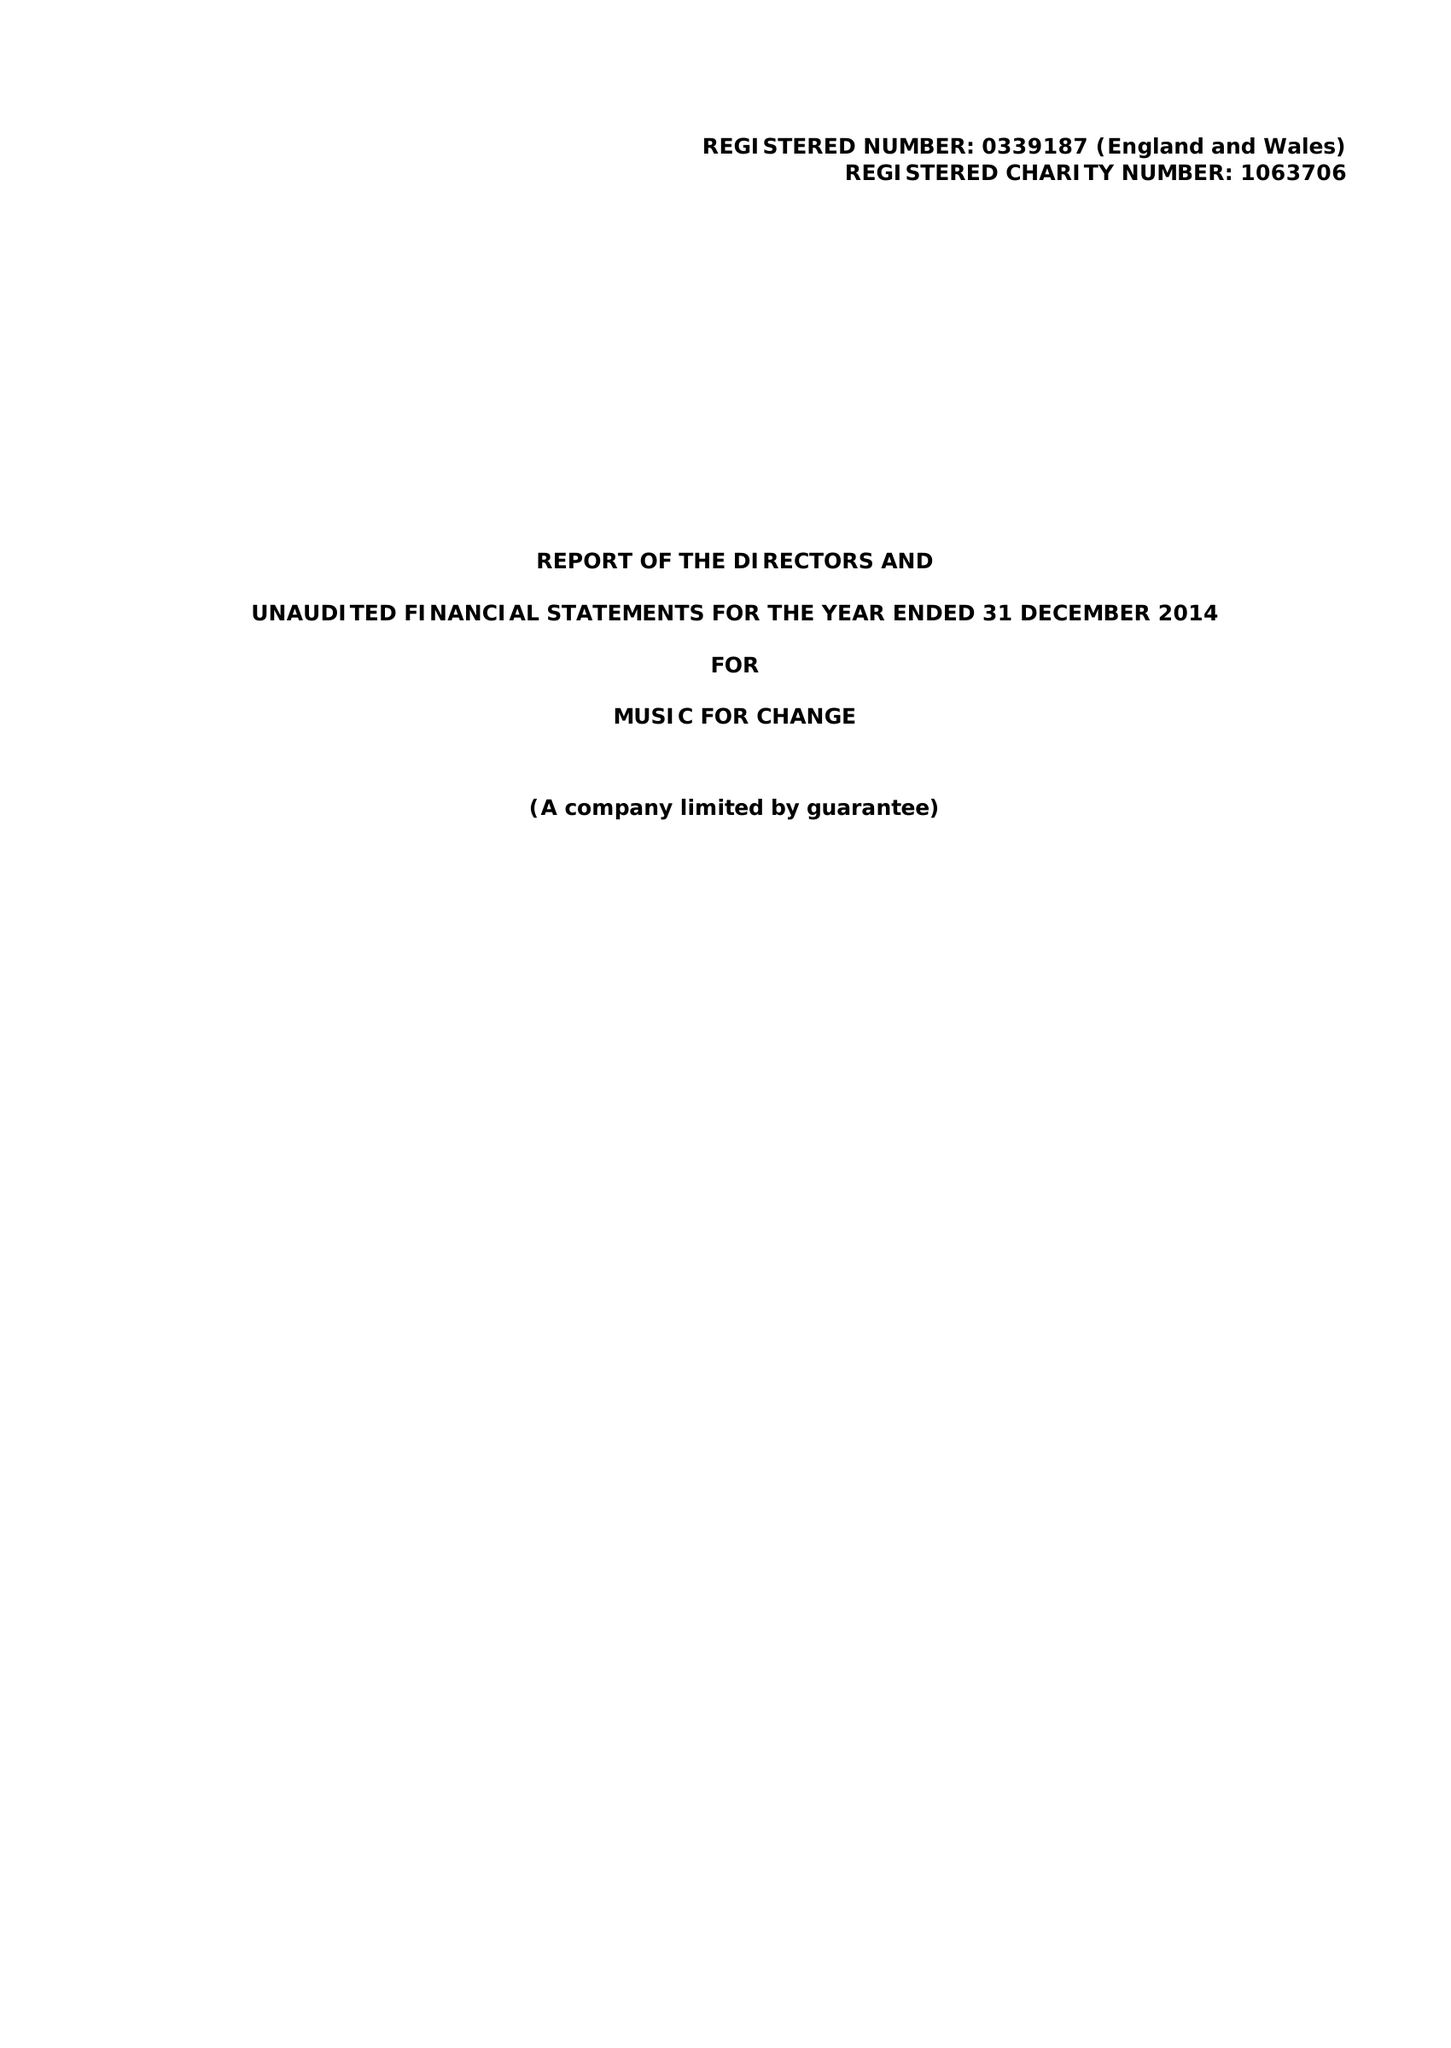What is the value for the address__street_line?
Answer the question using a single word or phrase. 77 STOUR STREET 